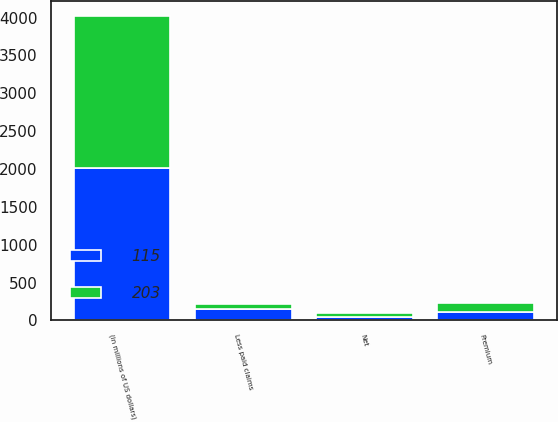<chart> <loc_0><loc_0><loc_500><loc_500><stacked_bar_chart><ecel><fcel>(in millions of US dollars)<fcel>Premium<fcel>Less paid claims<fcel>Net<nl><fcel>115<fcel>2009<fcel>109<fcel>151<fcel>42<nl><fcel>203<fcel>2008<fcel>122<fcel>68<fcel>54<nl></chart> 